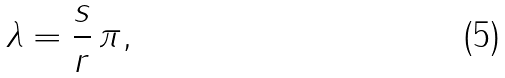Convert formula to latex. <formula><loc_0><loc_0><loc_500><loc_500>\lambda = \frac { s } { r } \, \pi ,</formula> 